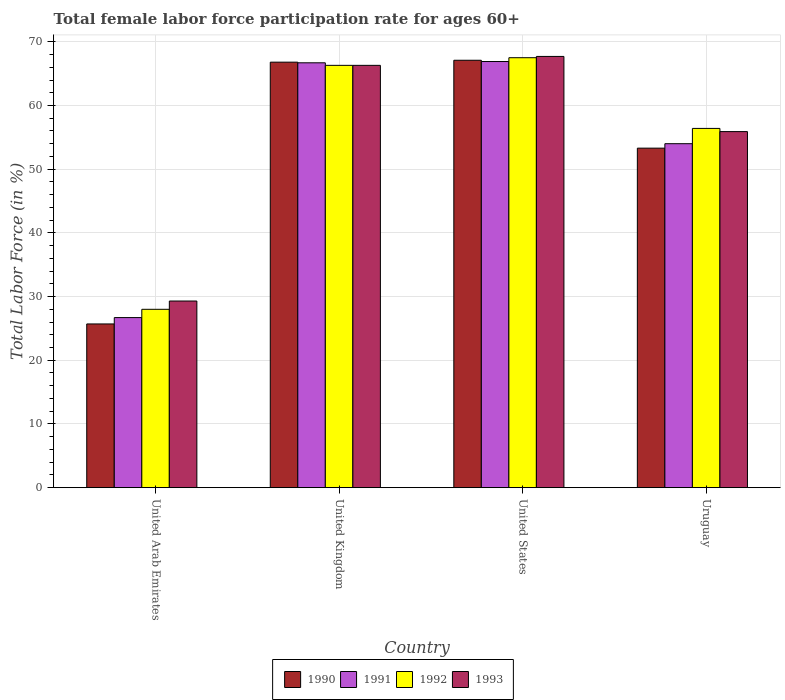How many groups of bars are there?
Offer a very short reply. 4. Are the number of bars on each tick of the X-axis equal?
Ensure brevity in your answer.  Yes. How many bars are there on the 1st tick from the left?
Keep it short and to the point. 4. How many bars are there on the 2nd tick from the right?
Offer a very short reply. 4. In how many cases, is the number of bars for a given country not equal to the number of legend labels?
Make the answer very short. 0. What is the female labor force participation rate in 1991 in United States?
Give a very brief answer. 66.9. Across all countries, what is the maximum female labor force participation rate in 1992?
Offer a very short reply. 67.5. Across all countries, what is the minimum female labor force participation rate in 1990?
Provide a succinct answer. 25.7. In which country was the female labor force participation rate in 1991 minimum?
Provide a succinct answer. United Arab Emirates. What is the total female labor force participation rate in 1991 in the graph?
Give a very brief answer. 214.3. What is the difference between the female labor force participation rate in 1991 in United Arab Emirates and that in United Kingdom?
Your answer should be compact. -40. What is the difference between the female labor force participation rate in 1991 in United Kingdom and the female labor force participation rate in 1993 in United States?
Give a very brief answer. -1. What is the average female labor force participation rate in 1990 per country?
Keep it short and to the point. 53.23. What is the difference between the female labor force participation rate of/in 1990 and female labor force participation rate of/in 1992 in United States?
Your response must be concise. -0.4. In how many countries, is the female labor force participation rate in 1991 greater than 44 %?
Provide a succinct answer. 3. What is the ratio of the female labor force participation rate in 1992 in United Arab Emirates to that in United Kingdom?
Offer a very short reply. 0.42. Is the female labor force participation rate in 1991 in United Arab Emirates less than that in United States?
Your answer should be compact. Yes. Is the difference between the female labor force participation rate in 1990 in United Arab Emirates and United States greater than the difference between the female labor force participation rate in 1992 in United Arab Emirates and United States?
Your answer should be very brief. No. What is the difference between the highest and the second highest female labor force participation rate in 1990?
Ensure brevity in your answer.  -0.3. What is the difference between the highest and the lowest female labor force participation rate in 1992?
Provide a succinct answer. 39.5. In how many countries, is the female labor force participation rate in 1990 greater than the average female labor force participation rate in 1990 taken over all countries?
Ensure brevity in your answer.  3. Is the sum of the female labor force participation rate in 1993 in United Kingdom and Uruguay greater than the maximum female labor force participation rate in 1992 across all countries?
Keep it short and to the point. Yes. What does the 3rd bar from the right in United Arab Emirates represents?
Provide a short and direct response. 1991. Is it the case that in every country, the sum of the female labor force participation rate in 1990 and female labor force participation rate in 1993 is greater than the female labor force participation rate in 1992?
Your response must be concise. Yes. How many bars are there?
Offer a very short reply. 16. Are all the bars in the graph horizontal?
Ensure brevity in your answer.  No. How many countries are there in the graph?
Make the answer very short. 4. What is the difference between two consecutive major ticks on the Y-axis?
Ensure brevity in your answer.  10. Are the values on the major ticks of Y-axis written in scientific E-notation?
Provide a succinct answer. No. Does the graph contain grids?
Offer a terse response. Yes. How are the legend labels stacked?
Ensure brevity in your answer.  Horizontal. What is the title of the graph?
Give a very brief answer. Total female labor force participation rate for ages 60+. What is the label or title of the X-axis?
Your answer should be very brief. Country. What is the label or title of the Y-axis?
Offer a terse response. Total Labor Force (in %). What is the Total Labor Force (in %) of 1990 in United Arab Emirates?
Your answer should be very brief. 25.7. What is the Total Labor Force (in %) of 1991 in United Arab Emirates?
Your answer should be compact. 26.7. What is the Total Labor Force (in %) of 1992 in United Arab Emirates?
Ensure brevity in your answer.  28. What is the Total Labor Force (in %) in 1993 in United Arab Emirates?
Your answer should be very brief. 29.3. What is the Total Labor Force (in %) in 1990 in United Kingdom?
Make the answer very short. 66.8. What is the Total Labor Force (in %) in 1991 in United Kingdom?
Your response must be concise. 66.7. What is the Total Labor Force (in %) of 1992 in United Kingdom?
Provide a succinct answer. 66.3. What is the Total Labor Force (in %) of 1993 in United Kingdom?
Your answer should be very brief. 66.3. What is the Total Labor Force (in %) of 1990 in United States?
Offer a terse response. 67.1. What is the Total Labor Force (in %) of 1991 in United States?
Offer a terse response. 66.9. What is the Total Labor Force (in %) in 1992 in United States?
Give a very brief answer. 67.5. What is the Total Labor Force (in %) of 1993 in United States?
Provide a succinct answer. 67.7. What is the Total Labor Force (in %) of 1990 in Uruguay?
Provide a short and direct response. 53.3. What is the Total Labor Force (in %) of 1991 in Uruguay?
Offer a very short reply. 54. What is the Total Labor Force (in %) in 1992 in Uruguay?
Provide a succinct answer. 56.4. What is the Total Labor Force (in %) in 1993 in Uruguay?
Provide a short and direct response. 55.9. Across all countries, what is the maximum Total Labor Force (in %) of 1990?
Give a very brief answer. 67.1. Across all countries, what is the maximum Total Labor Force (in %) in 1991?
Make the answer very short. 66.9. Across all countries, what is the maximum Total Labor Force (in %) of 1992?
Provide a succinct answer. 67.5. Across all countries, what is the maximum Total Labor Force (in %) of 1993?
Offer a very short reply. 67.7. Across all countries, what is the minimum Total Labor Force (in %) in 1990?
Give a very brief answer. 25.7. Across all countries, what is the minimum Total Labor Force (in %) in 1991?
Keep it short and to the point. 26.7. Across all countries, what is the minimum Total Labor Force (in %) in 1993?
Give a very brief answer. 29.3. What is the total Total Labor Force (in %) in 1990 in the graph?
Offer a very short reply. 212.9. What is the total Total Labor Force (in %) in 1991 in the graph?
Make the answer very short. 214.3. What is the total Total Labor Force (in %) in 1992 in the graph?
Make the answer very short. 218.2. What is the total Total Labor Force (in %) in 1993 in the graph?
Make the answer very short. 219.2. What is the difference between the Total Labor Force (in %) in 1990 in United Arab Emirates and that in United Kingdom?
Offer a terse response. -41.1. What is the difference between the Total Labor Force (in %) in 1991 in United Arab Emirates and that in United Kingdom?
Make the answer very short. -40. What is the difference between the Total Labor Force (in %) of 1992 in United Arab Emirates and that in United Kingdom?
Give a very brief answer. -38.3. What is the difference between the Total Labor Force (in %) of 1993 in United Arab Emirates and that in United Kingdom?
Give a very brief answer. -37. What is the difference between the Total Labor Force (in %) in 1990 in United Arab Emirates and that in United States?
Provide a succinct answer. -41.4. What is the difference between the Total Labor Force (in %) of 1991 in United Arab Emirates and that in United States?
Keep it short and to the point. -40.2. What is the difference between the Total Labor Force (in %) of 1992 in United Arab Emirates and that in United States?
Your answer should be compact. -39.5. What is the difference between the Total Labor Force (in %) of 1993 in United Arab Emirates and that in United States?
Ensure brevity in your answer.  -38.4. What is the difference between the Total Labor Force (in %) of 1990 in United Arab Emirates and that in Uruguay?
Your response must be concise. -27.6. What is the difference between the Total Labor Force (in %) in 1991 in United Arab Emirates and that in Uruguay?
Your response must be concise. -27.3. What is the difference between the Total Labor Force (in %) in 1992 in United Arab Emirates and that in Uruguay?
Your response must be concise. -28.4. What is the difference between the Total Labor Force (in %) of 1993 in United Arab Emirates and that in Uruguay?
Provide a succinct answer. -26.6. What is the difference between the Total Labor Force (in %) of 1990 in United Kingdom and that in United States?
Offer a terse response. -0.3. What is the difference between the Total Labor Force (in %) in 1992 in United Kingdom and that in United States?
Give a very brief answer. -1.2. What is the difference between the Total Labor Force (in %) of 1993 in United Kingdom and that in United States?
Your answer should be compact. -1.4. What is the difference between the Total Labor Force (in %) in 1990 in United States and that in Uruguay?
Give a very brief answer. 13.8. What is the difference between the Total Labor Force (in %) in 1991 in United States and that in Uruguay?
Give a very brief answer. 12.9. What is the difference between the Total Labor Force (in %) in 1993 in United States and that in Uruguay?
Provide a succinct answer. 11.8. What is the difference between the Total Labor Force (in %) in 1990 in United Arab Emirates and the Total Labor Force (in %) in 1991 in United Kingdom?
Ensure brevity in your answer.  -41. What is the difference between the Total Labor Force (in %) in 1990 in United Arab Emirates and the Total Labor Force (in %) in 1992 in United Kingdom?
Offer a terse response. -40.6. What is the difference between the Total Labor Force (in %) of 1990 in United Arab Emirates and the Total Labor Force (in %) of 1993 in United Kingdom?
Provide a succinct answer. -40.6. What is the difference between the Total Labor Force (in %) of 1991 in United Arab Emirates and the Total Labor Force (in %) of 1992 in United Kingdom?
Make the answer very short. -39.6. What is the difference between the Total Labor Force (in %) of 1991 in United Arab Emirates and the Total Labor Force (in %) of 1993 in United Kingdom?
Give a very brief answer. -39.6. What is the difference between the Total Labor Force (in %) of 1992 in United Arab Emirates and the Total Labor Force (in %) of 1993 in United Kingdom?
Provide a succinct answer. -38.3. What is the difference between the Total Labor Force (in %) in 1990 in United Arab Emirates and the Total Labor Force (in %) in 1991 in United States?
Give a very brief answer. -41.2. What is the difference between the Total Labor Force (in %) in 1990 in United Arab Emirates and the Total Labor Force (in %) in 1992 in United States?
Keep it short and to the point. -41.8. What is the difference between the Total Labor Force (in %) of 1990 in United Arab Emirates and the Total Labor Force (in %) of 1993 in United States?
Your response must be concise. -42. What is the difference between the Total Labor Force (in %) in 1991 in United Arab Emirates and the Total Labor Force (in %) in 1992 in United States?
Provide a succinct answer. -40.8. What is the difference between the Total Labor Force (in %) in 1991 in United Arab Emirates and the Total Labor Force (in %) in 1993 in United States?
Provide a short and direct response. -41. What is the difference between the Total Labor Force (in %) in 1992 in United Arab Emirates and the Total Labor Force (in %) in 1993 in United States?
Your answer should be very brief. -39.7. What is the difference between the Total Labor Force (in %) in 1990 in United Arab Emirates and the Total Labor Force (in %) in 1991 in Uruguay?
Make the answer very short. -28.3. What is the difference between the Total Labor Force (in %) in 1990 in United Arab Emirates and the Total Labor Force (in %) in 1992 in Uruguay?
Keep it short and to the point. -30.7. What is the difference between the Total Labor Force (in %) of 1990 in United Arab Emirates and the Total Labor Force (in %) of 1993 in Uruguay?
Give a very brief answer. -30.2. What is the difference between the Total Labor Force (in %) in 1991 in United Arab Emirates and the Total Labor Force (in %) in 1992 in Uruguay?
Keep it short and to the point. -29.7. What is the difference between the Total Labor Force (in %) in 1991 in United Arab Emirates and the Total Labor Force (in %) in 1993 in Uruguay?
Keep it short and to the point. -29.2. What is the difference between the Total Labor Force (in %) of 1992 in United Arab Emirates and the Total Labor Force (in %) of 1993 in Uruguay?
Ensure brevity in your answer.  -27.9. What is the difference between the Total Labor Force (in %) in 1990 in United Kingdom and the Total Labor Force (in %) in 1991 in United States?
Provide a succinct answer. -0.1. What is the difference between the Total Labor Force (in %) of 1991 in United Kingdom and the Total Labor Force (in %) of 1993 in United States?
Your response must be concise. -1. What is the difference between the Total Labor Force (in %) in 1991 in United Kingdom and the Total Labor Force (in %) in 1992 in Uruguay?
Provide a succinct answer. 10.3. What is the difference between the Total Labor Force (in %) of 1991 in United Kingdom and the Total Labor Force (in %) of 1993 in Uruguay?
Ensure brevity in your answer.  10.8. What is the difference between the Total Labor Force (in %) of 1990 in United States and the Total Labor Force (in %) of 1991 in Uruguay?
Offer a terse response. 13.1. What is the difference between the Total Labor Force (in %) of 1990 in United States and the Total Labor Force (in %) of 1993 in Uruguay?
Give a very brief answer. 11.2. What is the difference between the Total Labor Force (in %) of 1991 in United States and the Total Labor Force (in %) of 1992 in Uruguay?
Offer a terse response. 10.5. What is the difference between the Total Labor Force (in %) of 1991 in United States and the Total Labor Force (in %) of 1993 in Uruguay?
Offer a very short reply. 11. What is the average Total Labor Force (in %) in 1990 per country?
Your answer should be compact. 53.23. What is the average Total Labor Force (in %) of 1991 per country?
Give a very brief answer. 53.58. What is the average Total Labor Force (in %) in 1992 per country?
Your answer should be very brief. 54.55. What is the average Total Labor Force (in %) of 1993 per country?
Provide a short and direct response. 54.8. What is the difference between the Total Labor Force (in %) of 1990 and Total Labor Force (in %) of 1991 in United Arab Emirates?
Offer a very short reply. -1. What is the difference between the Total Labor Force (in %) of 1990 and Total Labor Force (in %) of 1992 in United Arab Emirates?
Your answer should be very brief. -2.3. What is the difference between the Total Labor Force (in %) of 1990 and Total Labor Force (in %) of 1993 in United Arab Emirates?
Keep it short and to the point. -3.6. What is the difference between the Total Labor Force (in %) of 1992 and Total Labor Force (in %) of 1993 in United Arab Emirates?
Keep it short and to the point. -1.3. What is the difference between the Total Labor Force (in %) in 1990 and Total Labor Force (in %) in 1993 in United Kingdom?
Offer a very short reply. 0.5. What is the difference between the Total Labor Force (in %) in 1991 and Total Labor Force (in %) in 1992 in United Kingdom?
Provide a short and direct response. 0.4. What is the difference between the Total Labor Force (in %) of 1991 and Total Labor Force (in %) of 1993 in United Kingdom?
Ensure brevity in your answer.  0.4. What is the difference between the Total Labor Force (in %) of 1990 and Total Labor Force (in %) of 1992 in United States?
Provide a short and direct response. -0.4. What is the difference between the Total Labor Force (in %) in 1990 and Total Labor Force (in %) in 1993 in United States?
Offer a very short reply. -0.6. What is the difference between the Total Labor Force (in %) of 1990 and Total Labor Force (in %) of 1993 in Uruguay?
Your response must be concise. -2.6. What is the difference between the Total Labor Force (in %) in 1991 and Total Labor Force (in %) in 1992 in Uruguay?
Your answer should be compact. -2.4. What is the difference between the Total Labor Force (in %) of 1991 and Total Labor Force (in %) of 1993 in Uruguay?
Keep it short and to the point. -1.9. What is the difference between the Total Labor Force (in %) in 1992 and Total Labor Force (in %) in 1993 in Uruguay?
Offer a very short reply. 0.5. What is the ratio of the Total Labor Force (in %) of 1990 in United Arab Emirates to that in United Kingdom?
Provide a succinct answer. 0.38. What is the ratio of the Total Labor Force (in %) of 1991 in United Arab Emirates to that in United Kingdom?
Give a very brief answer. 0.4. What is the ratio of the Total Labor Force (in %) of 1992 in United Arab Emirates to that in United Kingdom?
Ensure brevity in your answer.  0.42. What is the ratio of the Total Labor Force (in %) in 1993 in United Arab Emirates to that in United Kingdom?
Your answer should be very brief. 0.44. What is the ratio of the Total Labor Force (in %) of 1990 in United Arab Emirates to that in United States?
Provide a short and direct response. 0.38. What is the ratio of the Total Labor Force (in %) in 1991 in United Arab Emirates to that in United States?
Offer a terse response. 0.4. What is the ratio of the Total Labor Force (in %) in 1992 in United Arab Emirates to that in United States?
Your response must be concise. 0.41. What is the ratio of the Total Labor Force (in %) in 1993 in United Arab Emirates to that in United States?
Keep it short and to the point. 0.43. What is the ratio of the Total Labor Force (in %) of 1990 in United Arab Emirates to that in Uruguay?
Make the answer very short. 0.48. What is the ratio of the Total Labor Force (in %) of 1991 in United Arab Emirates to that in Uruguay?
Give a very brief answer. 0.49. What is the ratio of the Total Labor Force (in %) in 1992 in United Arab Emirates to that in Uruguay?
Your answer should be compact. 0.5. What is the ratio of the Total Labor Force (in %) of 1993 in United Arab Emirates to that in Uruguay?
Your response must be concise. 0.52. What is the ratio of the Total Labor Force (in %) in 1990 in United Kingdom to that in United States?
Ensure brevity in your answer.  1. What is the ratio of the Total Labor Force (in %) of 1991 in United Kingdom to that in United States?
Make the answer very short. 1. What is the ratio of the Total Labor Force (in %) of 1992 in United Kingdom to that in United States?
Provide a succinct answer. 0.98. What is the ratio of the Total Labor Force (in %) in 1993 in United Kingdom to that in United States?
Make the answer very short. 0.98. What is the ratio of the Total Labor Force (in %) in 1990 in United Kingdom to that in Uruguay?
Keep it short and to the point. 1.25. What is the ratio of the Total Labor Force (in %) of 1991 in United Kingdom to that in Uruguay?
Give a very brief answer. 1.24. What is the ratio of the Total Labor Force (in %) of 1992 in United Kingdom to that in Uruguay?
Make the answer very short. 1.18. What is the ratio of the Total Labor Force (in %) of 1993 in United Kingdom to that in Uruguay?
Your answer should be compact. 1.19. What is the ratio of the Total Labor Force (in %) of 1990 in United States to that in Uruguay?
Your answer should be compact. 1.26. What is the ratio of the Total Labor Force (in %) of 1991 in United States to that in Uruguay?
Give a very brief answer. 1.24. What is the ratio of the Total Labor Force (in %) of 1992 in United States to that in Uruguay?
Your answer should be very brief. 1.2. What is the ratio of the Total Labor Force (in %) of 1993 in United States to that in Uruguay?
Ensure brevity in your answer.  1.21. What is the difference between the highest and the second highest Total Labor Force (in %) of 1992?
Provide a succinct answer. 1.2. What is the difference between the highest and the second highest Total Labor Force (in %) of 1993?
Provide a succinct answer. 1.4. What is the difference between the highest and the lowest Total Labor Force (in %) in 1990?
Offer a terse response. 41.4. What is the difference between the highest and the lowest Total Labor Force (in %) of 1991?
Give a very brief answer. 40.2. What is the difference between the highest and the lowest Total Labor Force (in %) in 1992?
Offer a very short reply. 39.5. What is the difference between the highest and the lowest Total Labor Force (in %) of 1993?
Your answer should be very brief. 38.4. 